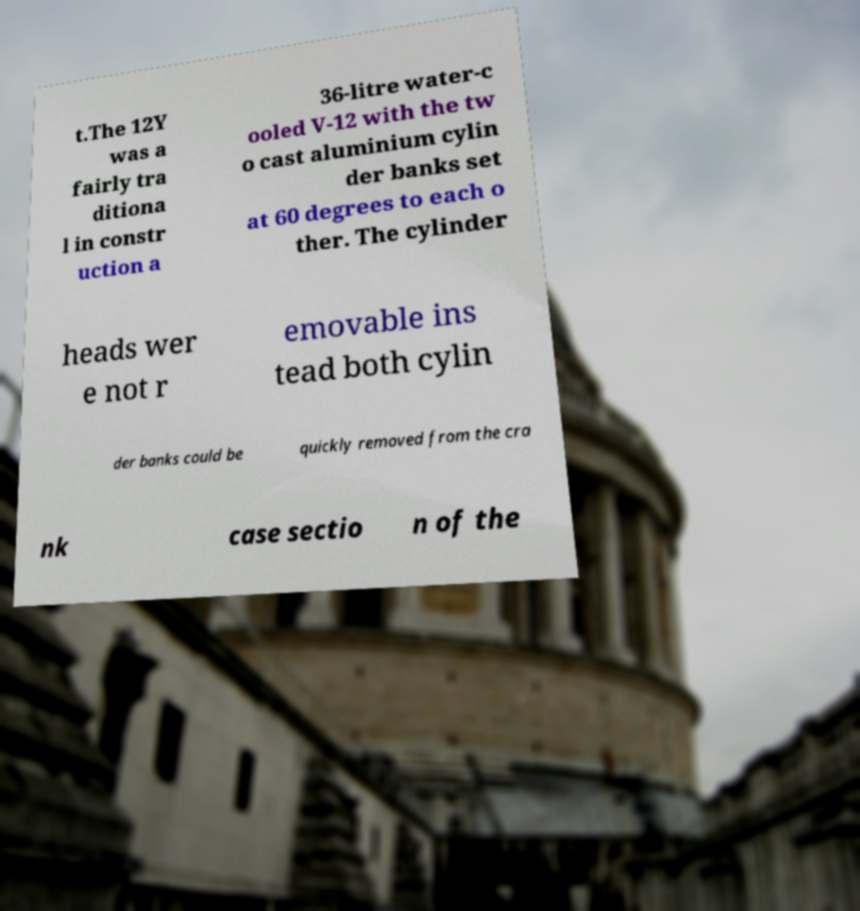Can you accurately transcribe the text from the provided image for me? t.The 12Y was a fairly tra ditiona l in constr uction a 36-litre water-c ooled V-12 with the tw o cast aluminium cylin der banks set at 60 degrees to each o ther. The cylinder heads wer e not r emovable ins tead both cylin der banks could be quickly removed from the cra nk case sectio n of the 